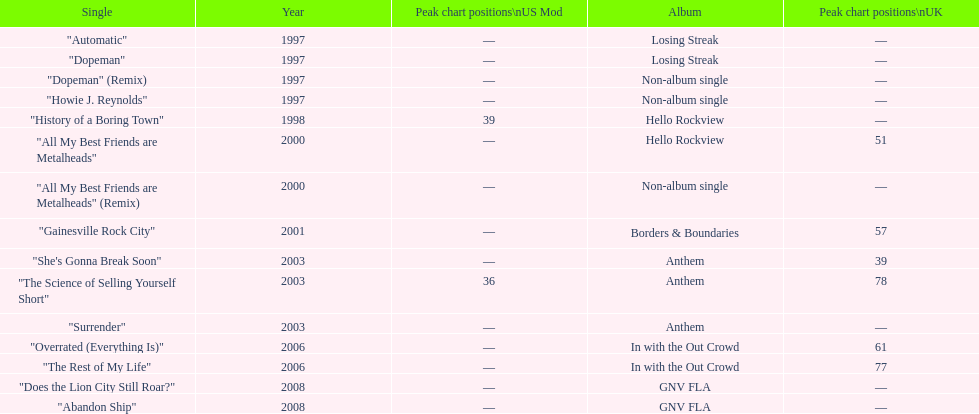Name one other single that was on the losing streak album besides "dopeman". "Automatic". 